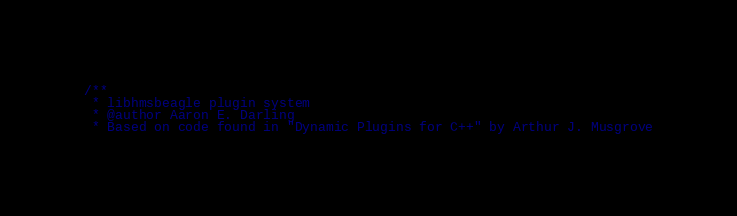<code> <loc_0><loc_0><loc_500><loc_500><_C_>/**
 * libhmsbeagle plugin system
 * @author Aaron E. Darling
 * Based on code found in "Dynamic Plugins for C++" by Arthur J. Musgrove</code> 